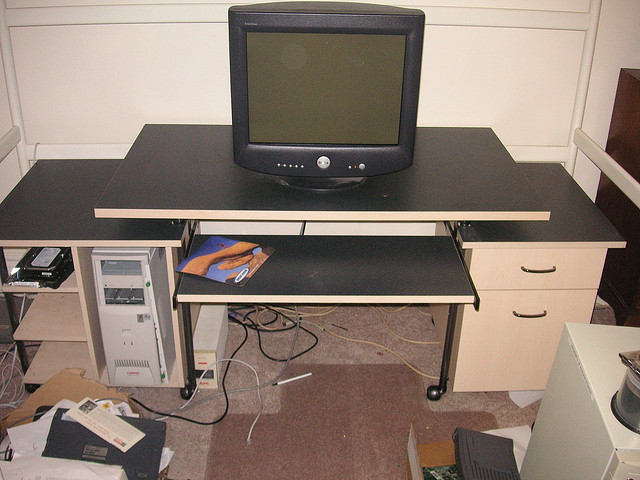How many people are lying down underneath the truck? There are no people lying down underneath the truck in the image, as there is no truck present. The image actually shows a room with a desk on which a CRT monitor is placed, along with various other items scattered around the room, such as a desktop computer tower to the left and miscellaneous papers and objects on the floor. 